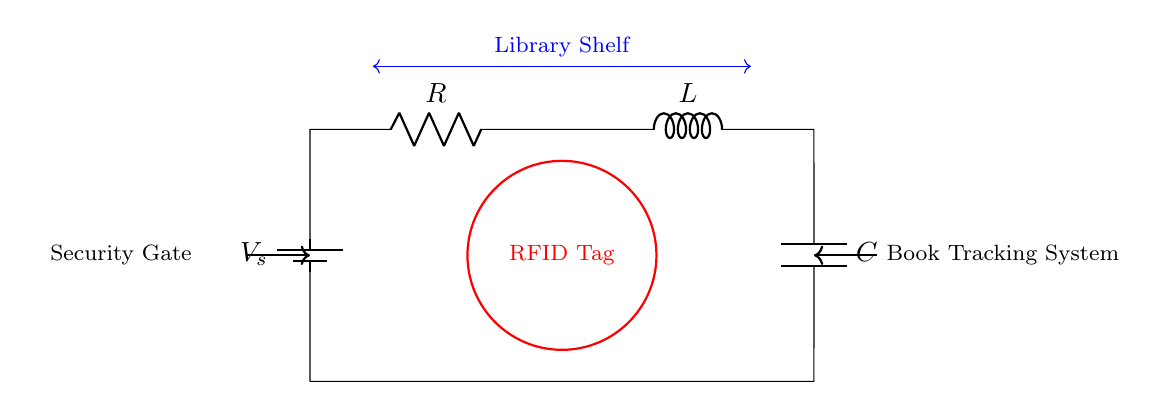What components are in this circuit? The circuit contains a resistor, inductor, and capacitor, which are the fundamental components of an RLC circuit. Additionally, there is a battery that provides voltage.
Answer: Resistor, Inductor, Capacitor What is the role of the RFID tag in this circuit? The RFID tag acts as a tracking device within the library’s book tracking system. It communicates with the security gate and monitors the status of books on the shelf.
Answer: Tracking device What is the function of the battery in this circuit? The battery provides the voltage source necessary to power the RLC circuit, enabling the operation of the RFID tag and any connected components.
Answer: Voltage source What type of circuit is this? This is an RLC circuit, characterized by the presence of a resistor, inductor, and capacitor connected in series.
Answer: RLC circuit How does the inductor impact the circuit? The inductor affects the current flow, introducing inductance which causes a phase shift between voltage and current, essential for resonating frequencies in RFID applications.
Answer: Phase shift Why are there connections to both the security gate and the library shelf? The connections indicate a system designed for monitoring interactions between the library’s security gate and the placement of books on the shelf, enhancing the RFID tracking capabilities.
Answer: Monitoring interactions 